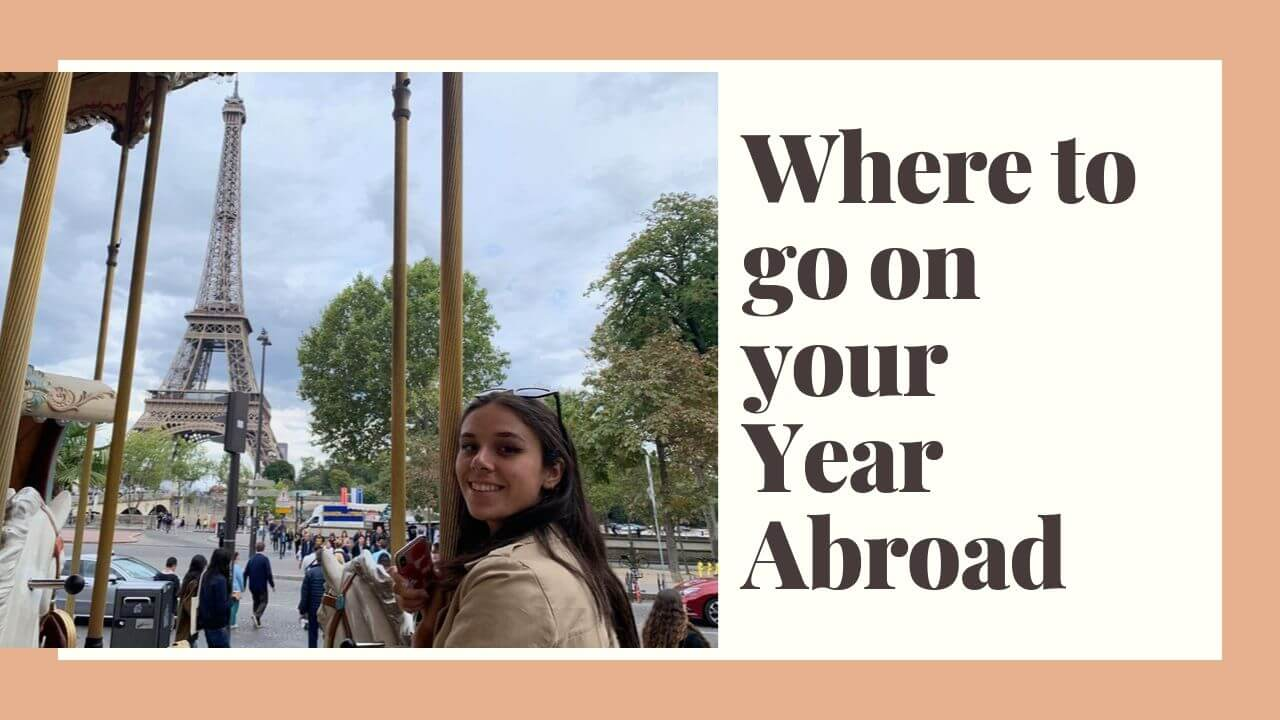The image feels part of a whimsically creative series. Can you explain a potential next scene in this series? The next image in this creative series could depict the woman exploring a quaint Parisian market. Vibrant stalls filled with fresh produce, flowers, and artisan goods line the streets. She’s seen picking up a beautiful, handmade journal, hinting at her love for capturing memories. In another corner, a street musician plays an accordion, adding to the enchanting ambiance. The scene is alive with color, sound, and the delightful hustle of everyday Parisian life. 